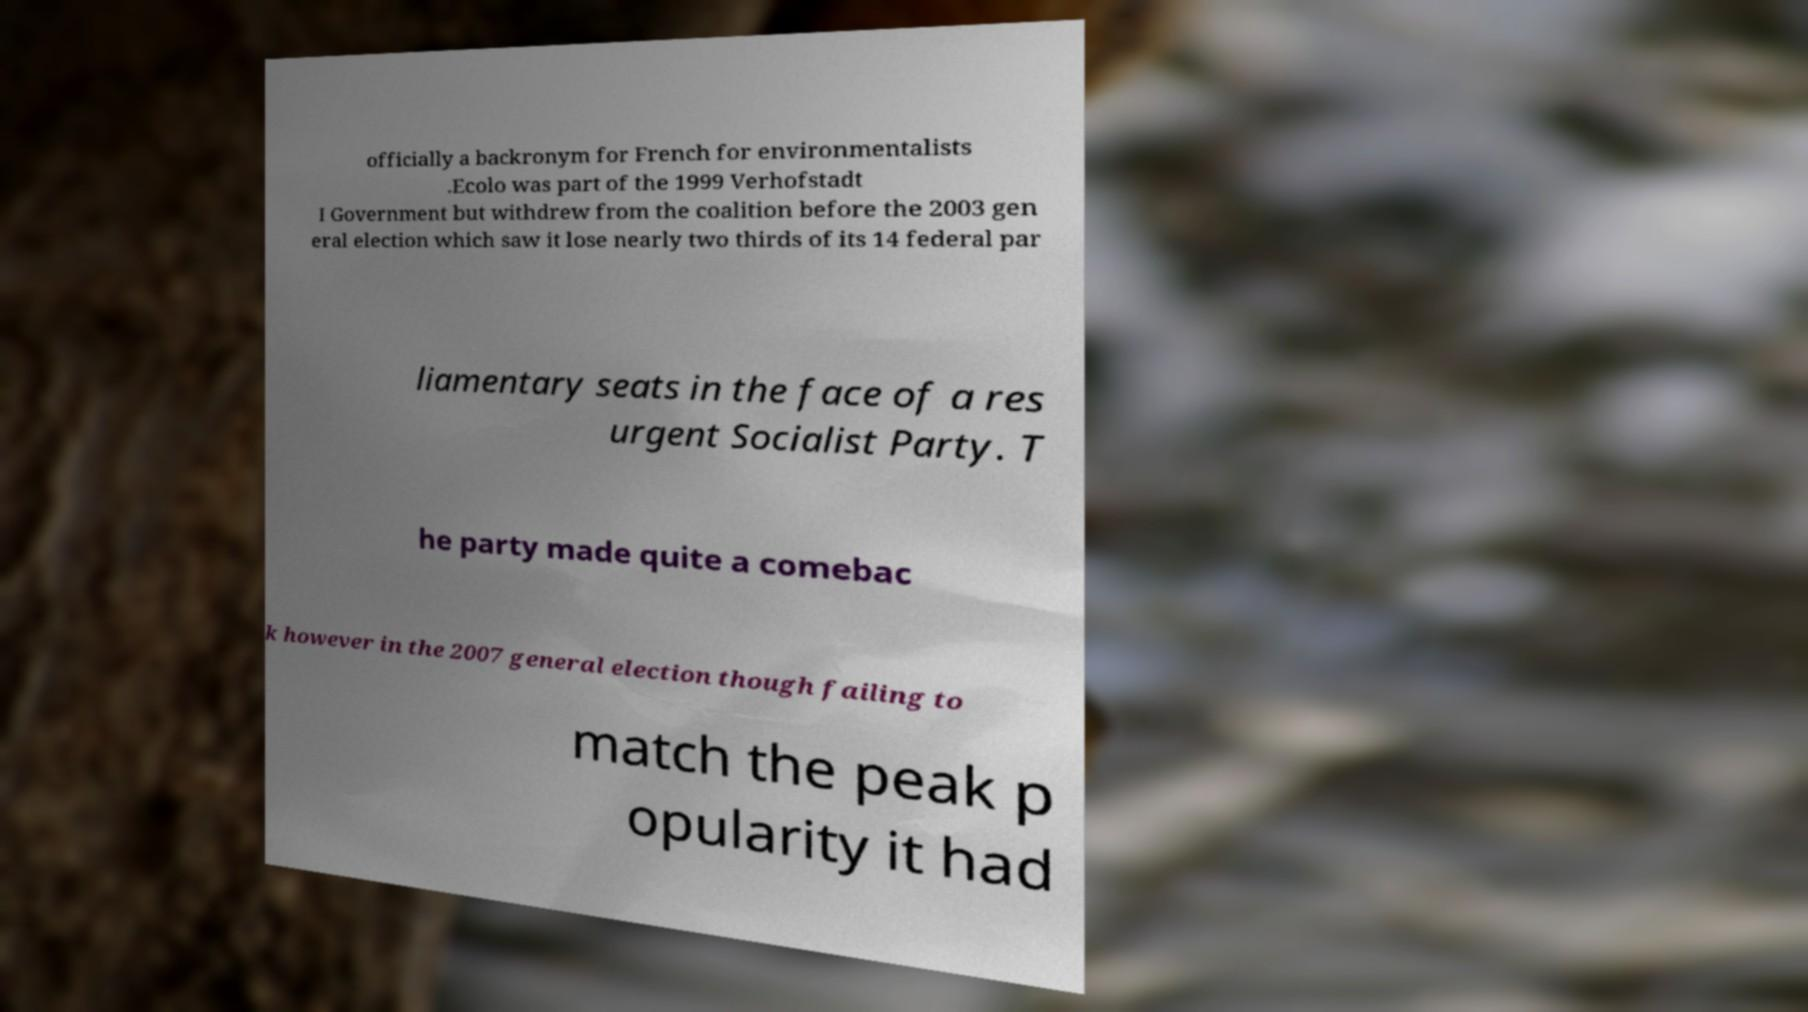Could you assist in decoding the text presented in this image and type it out clearly? officially a backronym for French for environmentalists .Ecolo was part of the 1999 Verhofstadt I Government but withdrew from the coalition before the 2003 gen eral election which saw it lose nearly two thirds of its 14 federal par liamentary seats in the face of a res urgent Socialist Party. T he party made quite a comebac k however in the 2007 general election though failing to match the peak p opularity it had 